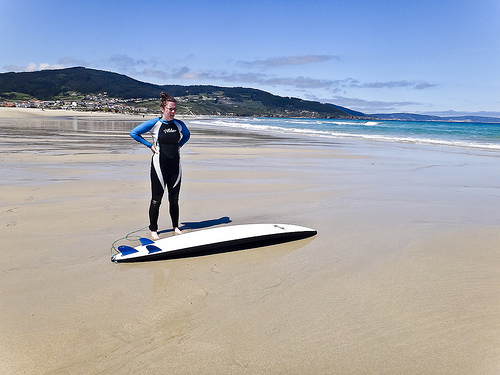Please provide a short description for this region: [0.01, 0.24, 0.99, 0.36]. The described area prominently features lush, forested mountains stretching across the horizon, offering a stunning and serene backdrop to the beach below. 